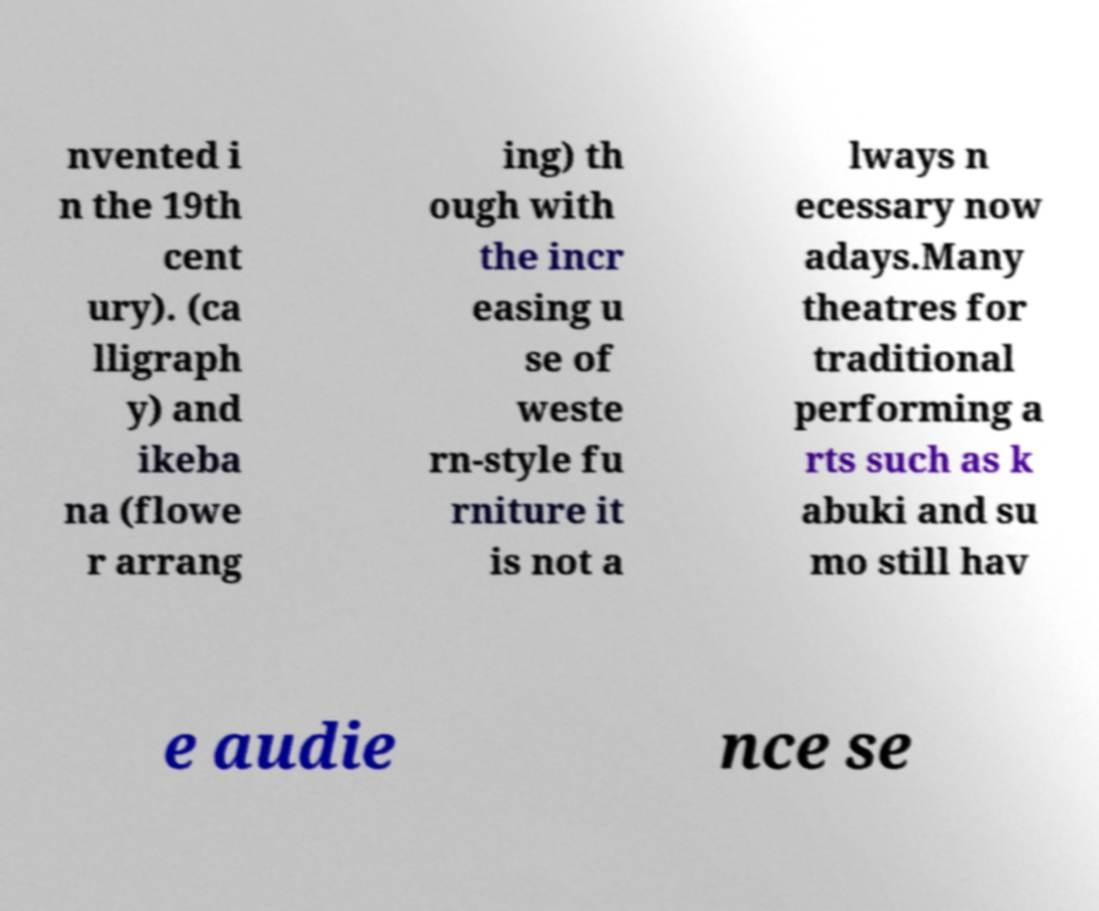Can you accurately transcribe the text from the provided image for me? nvented i n the 19th cent ury). (ca lligraph y) and ikeba na (flowe r arrang ing) th ough with the incr easing u se of weste rn-style fu rniture it is not a lways n ecessary now adays.Many theatres for traditional performing a rts such as k abuki and su mo still hav e audie nce se 